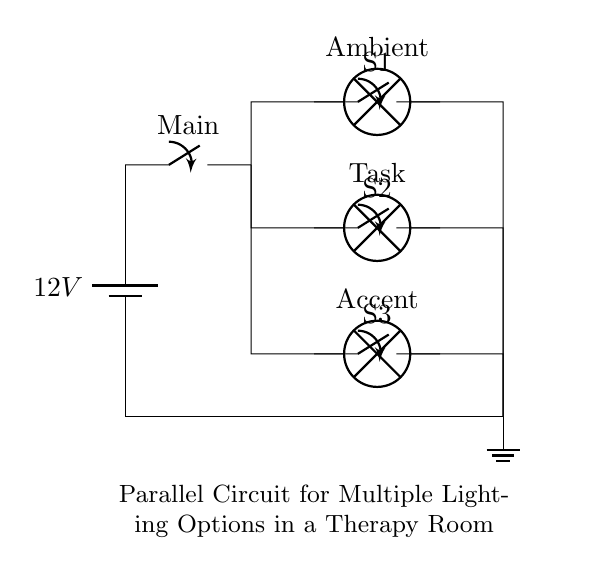What is the voltage of this circuit? The voltage is 12 volts, which is marked on the battery in the circuit. This indicates the potential difference supplied by the power source connected at the top.
Answer: 12 volts What types of lamps are present in the circuit? There are three types of lamps: Ambient, Task, and Accent. Each lamp is labeled in the diagram, allowing for easy identification of their purpose.
Answer: Ambient, Task, Accent How many switches are in the circuit? There are three individual switches, each positioned along the branches of the parallel circuit, allowing control over each lamp independently.
Answer: Three What happens if one lamp is turned off? If one lamp is turned off, the other lamps will remain lit, as this is a parallel circuit configuration where each branch operates independently.
Answer: Other lamps stay lit Which switch controls the Ambient lamp? The switch labeled S1 controls the Ambient lamp, which is located in the first branch of the circuit as shown in the diagram.
Answer: S1 What is the main purpose of this circuit configuration? The main purpose of this parallel circuit configuration is to provide multiple lighting options in the therapy room to adjust ambiance effectively for various activities or moods.
Answer: Multiple lighting options 